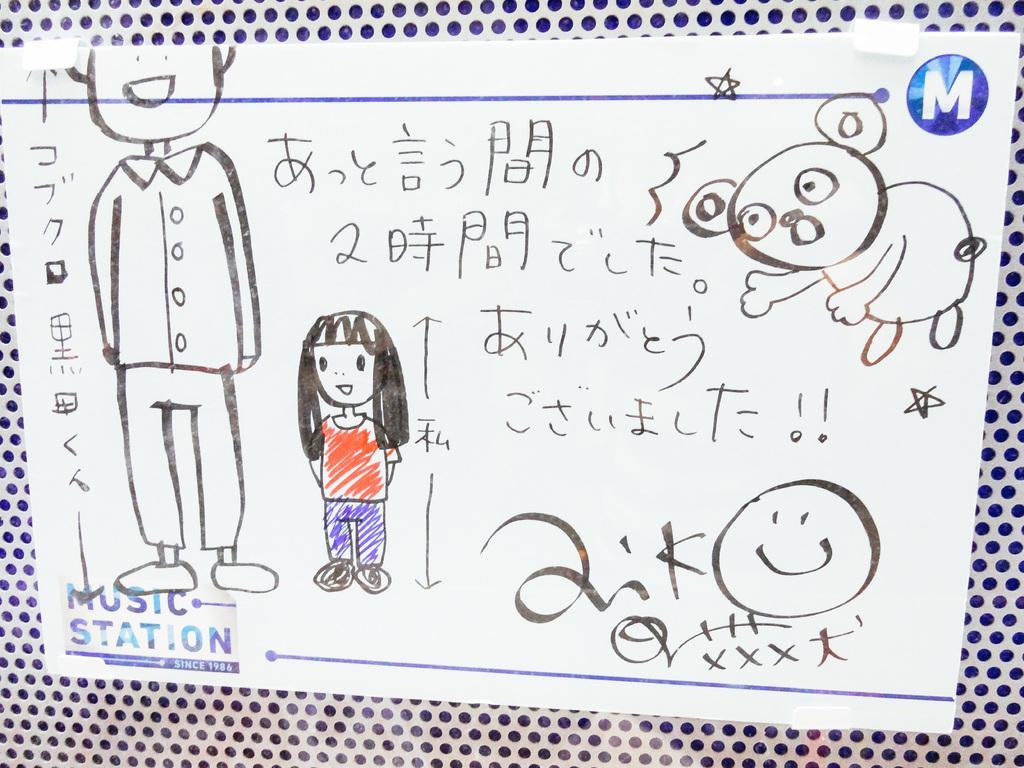In one or two sentences, can you explain what this image depicts? In this picture we can see some drawings and words on the paper and on the paper there are stamp marks and the paper is on an object. 